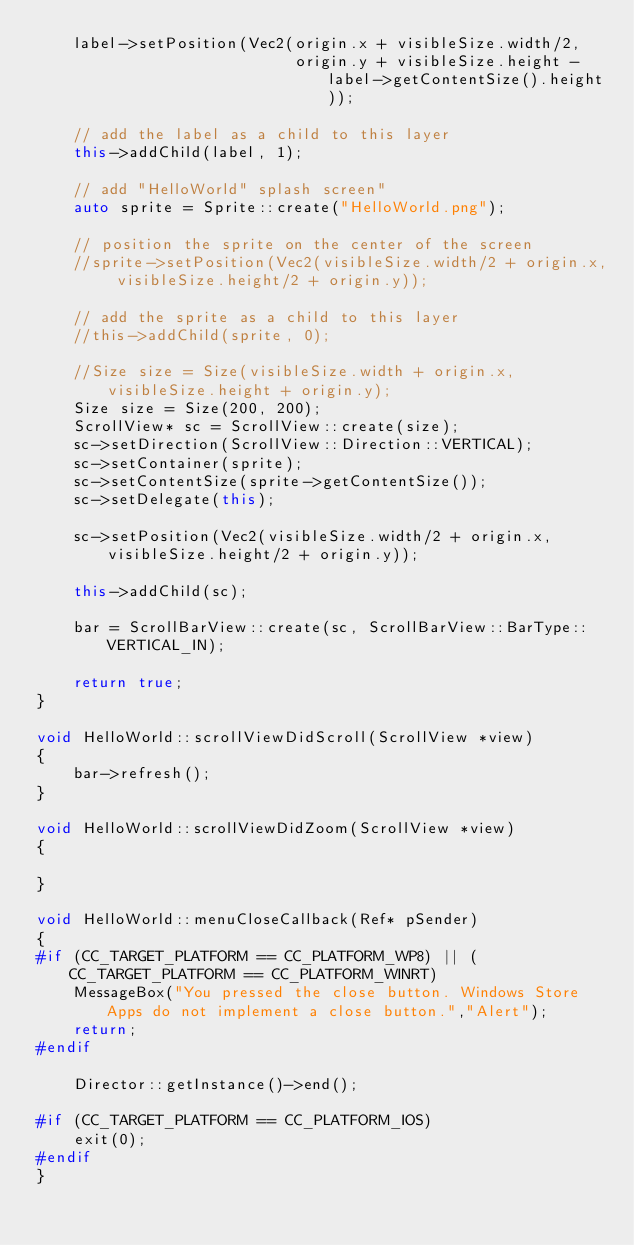<code> <loc_0><loc_0><loc_500><loc_500><_C++_>    label->setPosition(Vec2(origin.x + visibleSize.width/2,
                            origin.y + visibleSize.height - label->getContentSize().height));

    // add the label as a child to this layer
    this->addChild(label, 1);

    // add "HelloWorld" splash screen"
    auto sprite = Sprite::create("HelloWorld.png");

    // position the sprite on the center of the screen
    //sprite->setPosition(Vec2(visibleSize.width/2 + origin.x, visibleSize.height/2 + origin.y));

    // add the sprite as a child to this layer
    //this->addChild(sprite, 0);
    
    //Size size = Size(visibleSize.width + origin.x, visibleSize.height + origin.y);
    Size size = Size(200, 200);
    ScrollView* sc = ScrollView::create(size);
    sc->setDirection(ScrollView::Direction::VERTICAL);
    sc->setContainer(sprite);
    sc->setContentSize(sprite->getContentSize());
    sc->setDelegate(this);
    
    sc->setPosition(Vec2(visibleSize.width/2 + origin.x, visibleSize.height/2 + origin.y));
    
    this->addChild(sc);
    
    bar = ScrollBarView::create(sc, ScrollBarView::BarType::VERTICAL_IN);
    
    return true;
}

void HelloWorld::scrollViewDidScroll(ScrollView *view)
{
    bar->refresh();
}

void HelloWorld::scrollViewDidZoom(ScrollView *view)
{
    
}

void HelloWorld::menuCloseCallback(Ref* pSender)
{
#if (CC_TARGET_PLATFORM == CC_PLATFORM_WP8) || (CC_TARGET_PLATFORM == CC_PLATFORM_WINRT)
	MessageBox("You pressed the close button. Windows Store Apps do not implement a close button.","Alert");
    return;
#endif

    Director::getInstance()->end();

#if (CC_TARGET_PLATFORM == CC_PLATFORM_IOS)
    exit(0);
#endif
}
</code> 